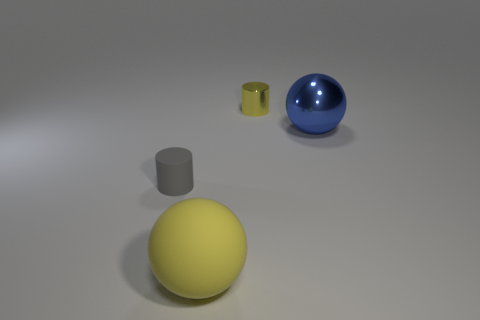Add 3 cylinders. How many objects exist? 7 Add 3 big yellow spheres. How many big yellow spheres are left? 4 Add 4 large red spheres. How many large red spheres exist? 4 Subtract 0 green cylinders. How many objects are left? 4 Subtract all gray matte cylinders. Subtract all gray cylinders. How many objects are left? 2 